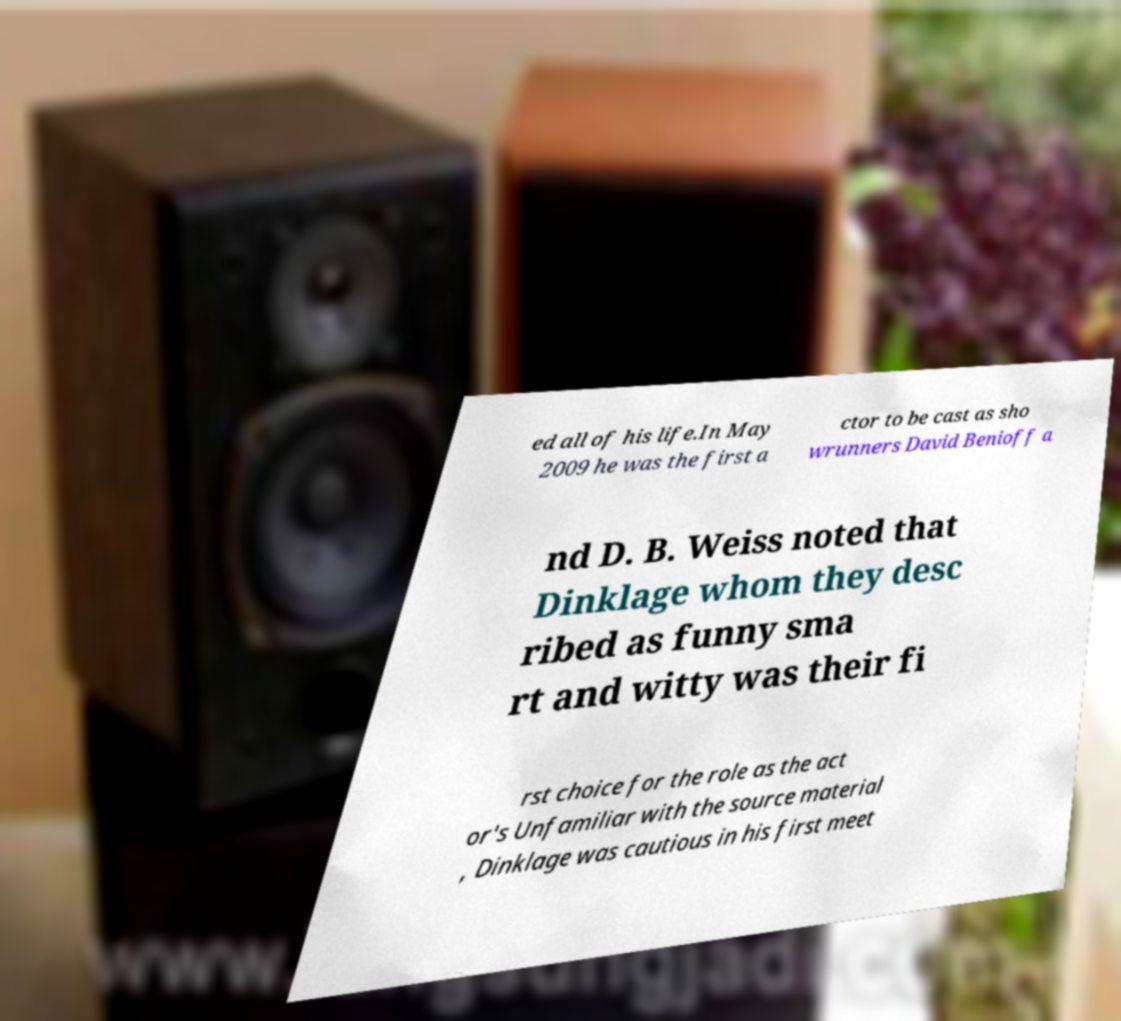Can you accurately transcribe the text from the provided image for me? ed all of his life.In May 2009 he was the first a ctor to be cast as sho wrunners David Benioff a nd D. B. Weiss noted that Dinklage whom they desc ribed as funny sma rt and witty was their fi rst choice for the role as the act or's Unfamiliar with the source material , Dinklage was cautious in his first meet 